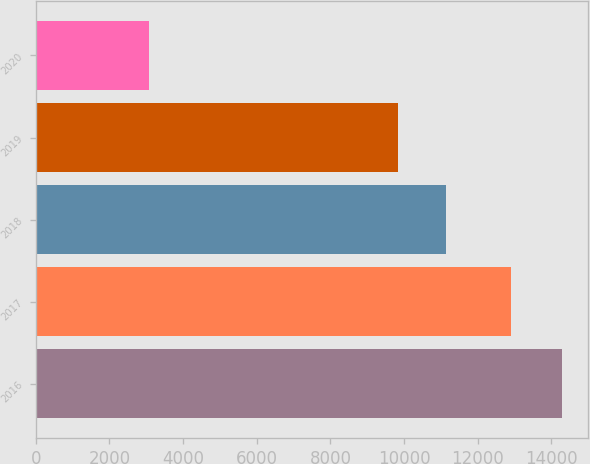Convert chart to OTSL. <chart><loc_0><loc_0><loc_500><loc_500><bar_chart><fcel>2016<fcel>2017<fcel>2018<fcel>2019<fcel>2020<nl><fcel>14290<fcel>12908<fcel>11135<fcel>9825<fcel>3076<nl></chart> 